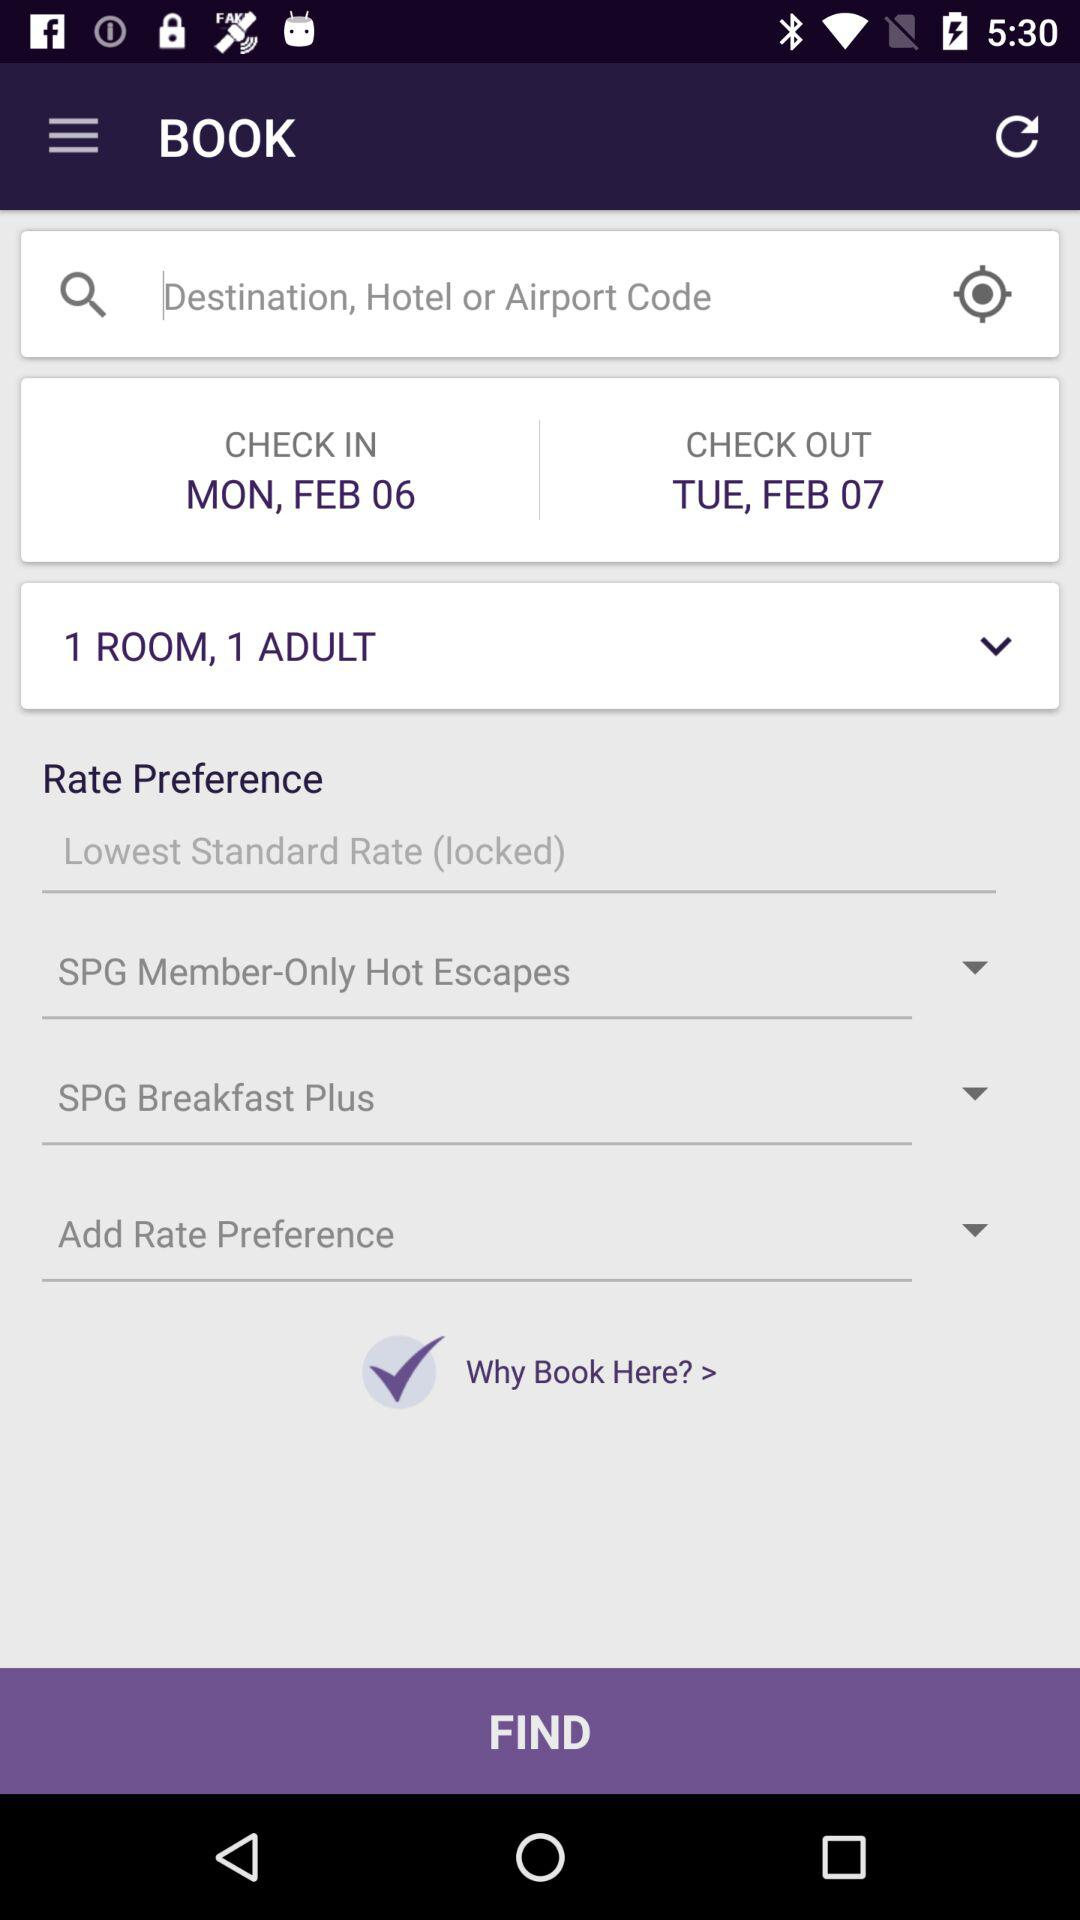What is the check-out date? The check-out date is Tuesday, February 7. 